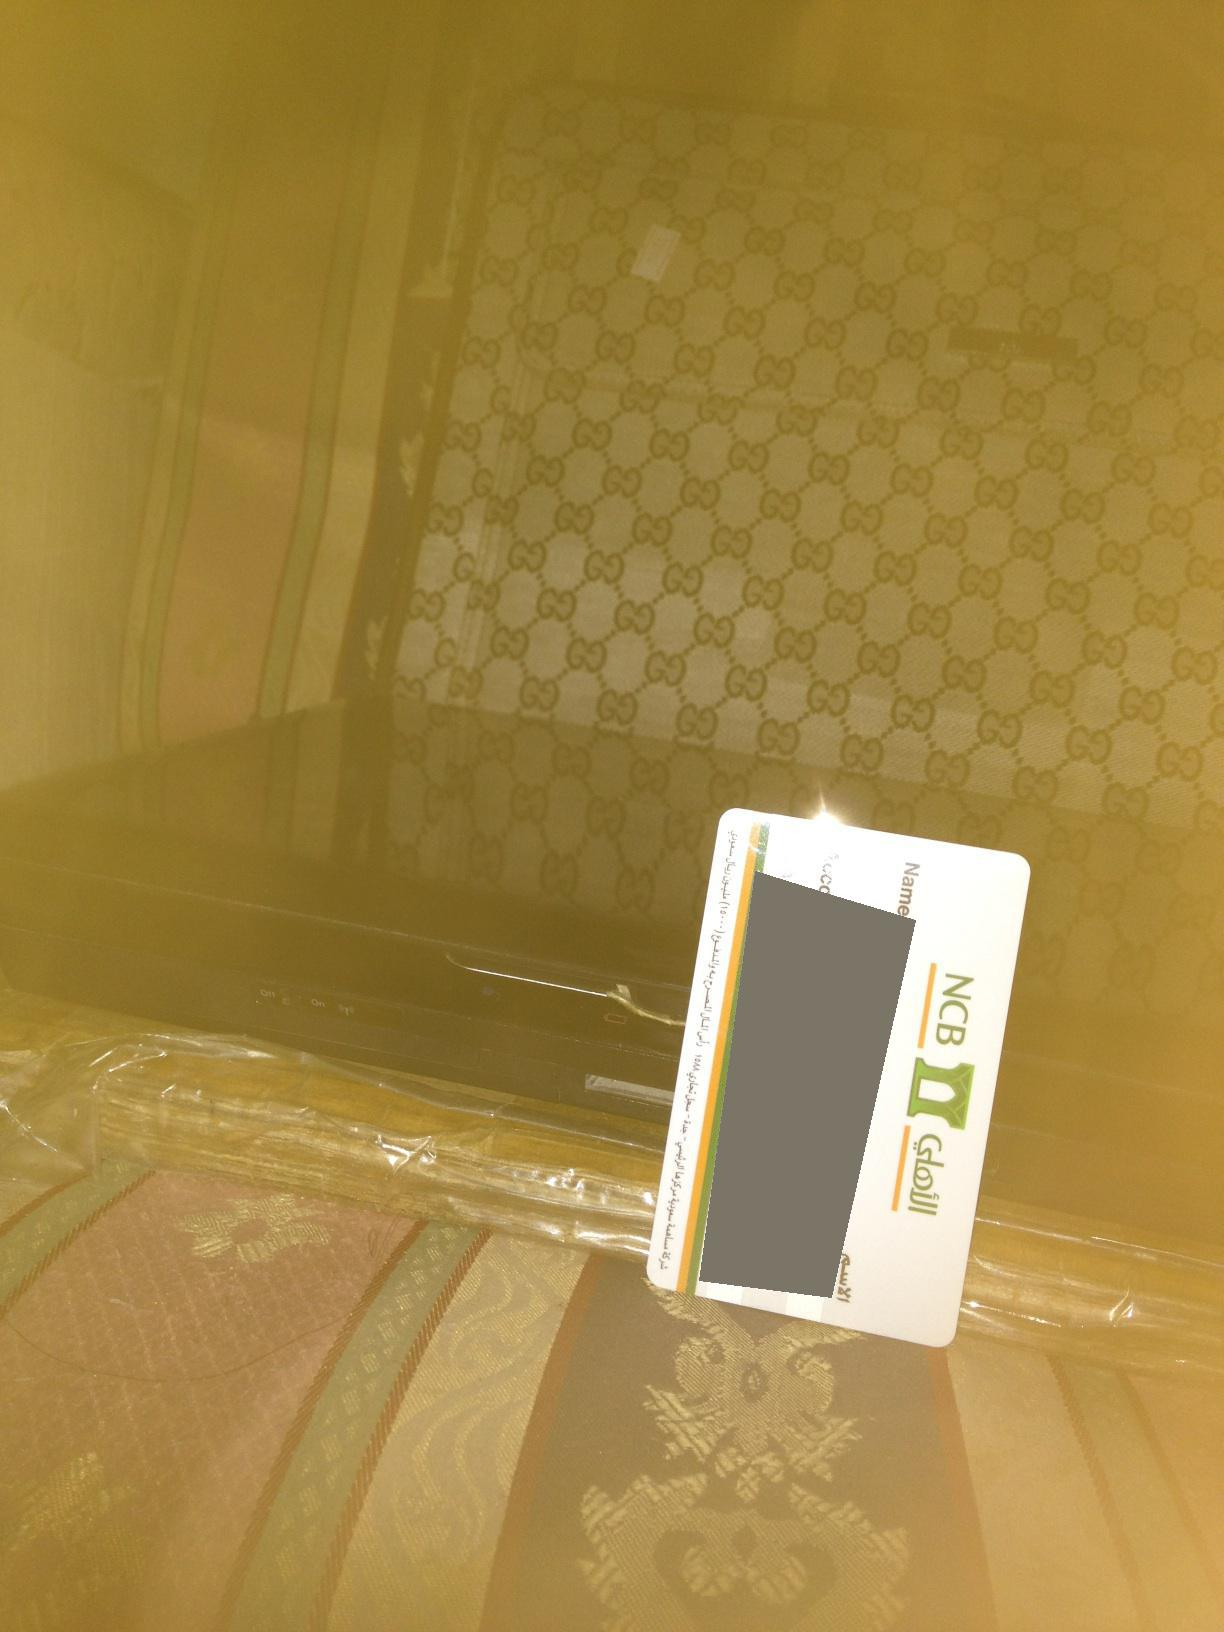is it not? The question is not specific enough to provide an accurate answer. Could you please provide more context or details? 